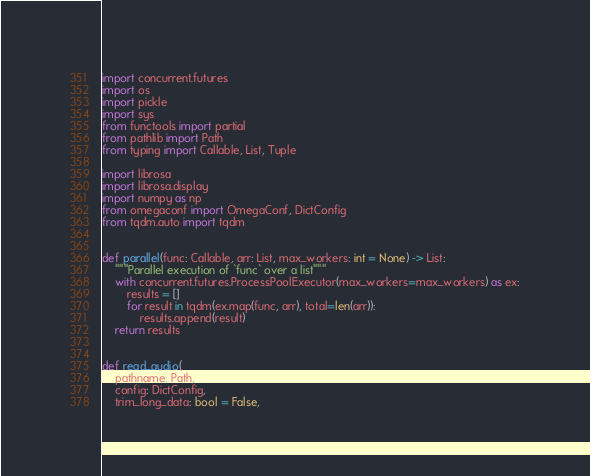<code> <loc_0><loc_0><loc_500><loc_500><_Python_>import concurrent.futures
import os
import pickle
import sys
from functools import partial
from pathlib import Path
from typing import Callable, List, Tuple

import librosa
import librosa.display
import numpy as np
from omegaconf import OmegaConf, DictConfig
from tqdm.auto import tqdm


def parallel(func: Callable, arr: List, max_workers: int = None) -> List:
    """Parallel execution of `func` over a list"""
    with concurrent.futures.ProcessPoolExecutor(max_workers=max_workers) as ex:
        results = []
        for result in tqdm(ex.map(func, arr), total=len(arr)):
            results.append(result)
    return results


def read_audio(
    pathname: Path,
    config: DictConfig,
    trim_long_data: bool = False,</code> 